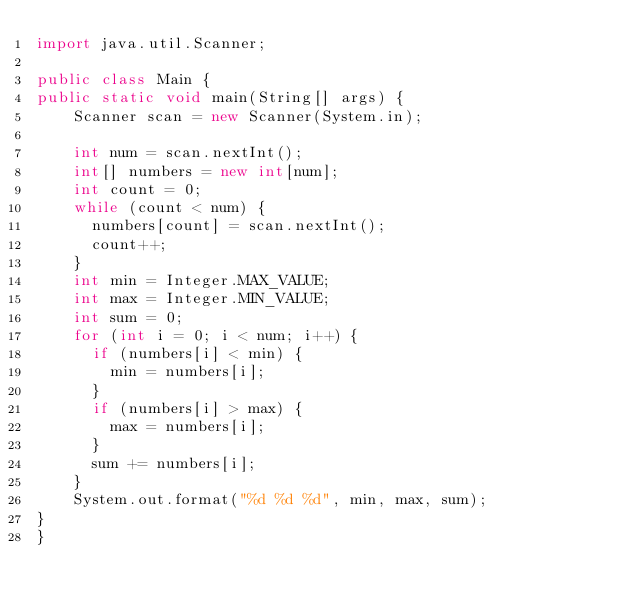<code> <loc_0><loc_0><loc_500><loc_500><_Java_>import java.util.Scanner;

public class Main {
public static void main(String[] args) {
		Scanner scan = new Scanner(System.in);

		int num = scan.nextInt();
		int[] numbers = new int[num];
		int count = 0;
		while (count < num) {
			numbers[count] = scan.nextInt();
			count++;
		}
		int min = Integer.MAX_VALUE;
		int max = Integer.MIN_VALUE;
		int sum = 0;
		for (int i = 0; i < num; i++) {
			if (numbers[i] < min) {
				min = numbers[i];
			}
			if (numbers[i] > max) {
				max = numbers[i];
			}
			sum += numbers[i];
		}
		System.out.format("%d %d %d", min, max, sum);
} 
}



</code> 